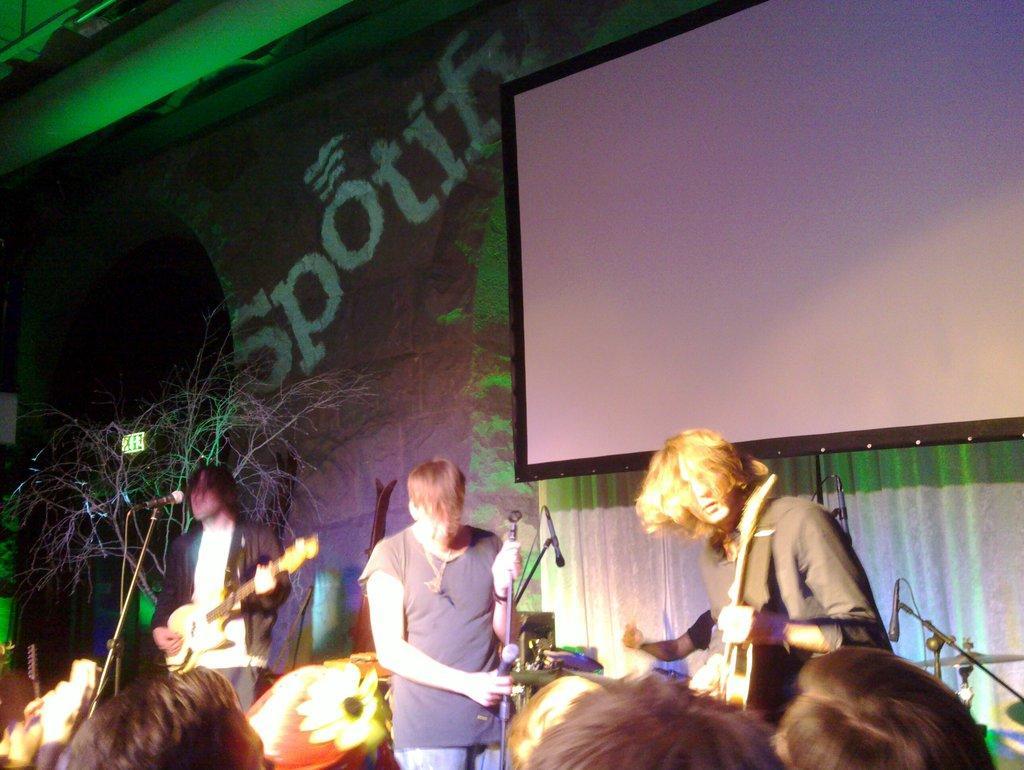Could you give a brief overview of what you see in this image? Bottom of the image few people are standing and playing some musical instruments and there are some microphones. Top right side of the image there is a screen. Top left side of the image there is a banner. 